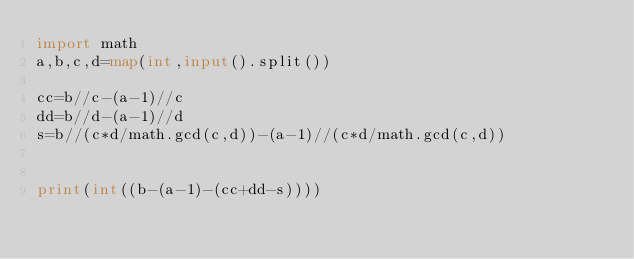Convert code to text. <code><loc_0><loc_0><loc_500><loc_500><_Python_>import math
a,b,c,d=map(int,input().split())

cc=b//c-(a-1)//c
dd=b//d-(a-1)//d
s=b//(c*d/math.gcd(c,d))-(a-1)//(c*d/math.gcd(c,d))


print(int((b-(a-1)-(cc+dd-s))))</code> 